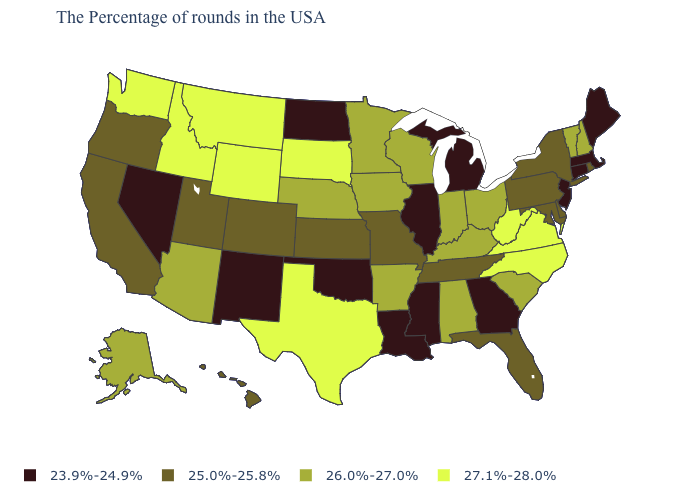Among the states that border Oregon , which have the highest value?
Answer briefly. Idaho, Washington. Among the states that border North Dakota , does Montana have the lowest value?
Quick response, please. No. Among the states that border Wyoming , which have the lowest value?
Quick response, please. Colorado, Utah. What is the value of Vermont?
Write a very short answer. 26.0%-27.0%. What is the value of Alaska?
Quick response, please. 26.0%-27.0%. How many symbols are there in the legend?
Be succinct. 4. Among the states that border Alabama , does Tennessee have the highest value?
Give a very brief answer. Yes. Among the states that border Alabama , which have the highest value?
Concise answer only. Florida, Tennessee. Among the states that border Arkansas , does Tennessee have the highest value?
Quick response, please. No. Name the states that have a value in the range 27.1%-28.0%?
Write a very short answer. Virginia, North Carolina, West Virginia, Texas, South Dakota, Wyoming, Montana, Idaho, Washington. What is the value of Indiana?
Answer briefly. 26.0%-27.0%. What is the value of Delaware?
Keep it brief. 25.0%-25.8%. Does South Dakota have the highest value in the MidWest?
Give a very brief answer. Yes. Among the states that border Oklahoma , which have the lowest value?
Write a very short answer. New Mexico. What is the lowest value in states that border Nevada?
Keep it brief. 25.0%-25.8%. 